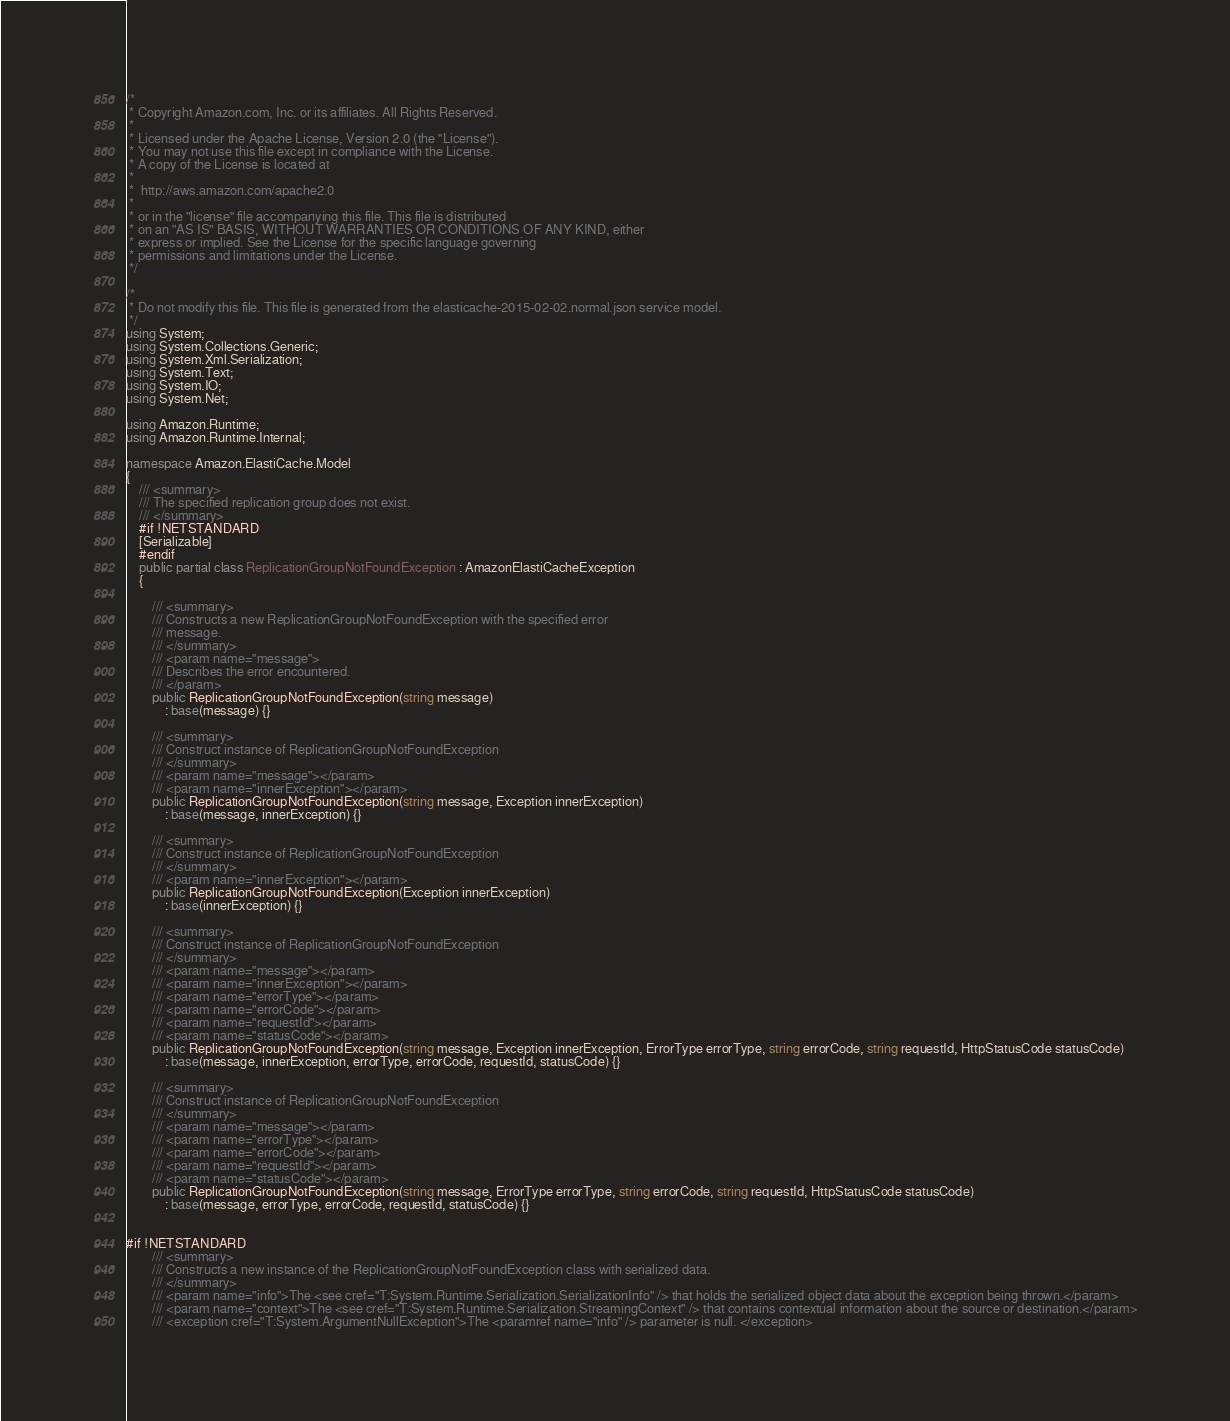Convert code to text. <code><loc_0><loc_0><loc_500><loc_500><_C#_>/*
 * Copyright Amazon.com, Inc. or its affiliates. All Rights Reserved.
 * 
 * Licensed under the Apache License, Version 2.0 (the "License").
 * You may not use this file except in compliance with the License.
 * A copy of the License is located at
 * 
 *  http://aws.amazon.com/apache2.0
 * 
 * or in the "license" file accompanying this file. This file is distributed
 * on an "AS IS" BASIS, WITHOUT WARRANTIES OR CONDITIONS OF ANY KIND, either
 * express or implied. See the License for the specific language governing
 * permissions and limitations under the License.
 */

/*
 * Do not modify this file. This file is generated from the elasticache-2015-02-02.normal.json service model.
 */
using System;
using System.Collections.Generic;
using System.Xml.Serialization;
using System.Text;
using System.IO;
using System.Net;

using Amazon.Runtime;
using Amazon.Runtime.Internal;

namespace Amazon.ElastiCache.Model
{
    /// <summary>
    /// The specified replication group does not exist.
    /// </summary>
    #if !NETSTANDARD
    [Serializable]
    #endif
    public partial class ReplicationGroupNotFoundException : AmazonElastiCacheException
    {

        /// <summary>
        /// Constructs a new ReplicationGroupNotFoundException with the specified error
        /// message.
        /// </summary>
        /// <param name="message">
        /// Describes the error encountered.
        /// </param>
        public ReplicationGroupNotFoundException(string message) 
            : base(message) {}

        /// <summary>
        /// Construct instance of ReplicationGroupNotFoundException
        /// </summary>
        /// <param name="message"></param>
        /// <param name="innerException"></param>
        public ReplicationGroupNotFoundException(string message, Exception innerException) 
            : base(message, innerException) {}

        /// <summary>
        /// Construct instance of ReplicationGroupNotFoundException
        /// </summary>
        /// <param name="innerException"></param>
        public ReplicationGroupNotFoundException(Exception innerException) 
            : base(innerException) {}

        /// <summary>
        /// Construct instance of ReplicationGroupNotFoundException
        /// </summary>
        /// <param name="message"></param>
        /// <param name="innerException"></param>
        /// <param name="errorType"></param>
        /// <param name="errorCode"></param>
        /// <param name="requestId"></param>
        /// <param name="statusCode"></param>
        public ReplicationGroupNotFoundException(string message, Exception innerException, ErrorType errorType, string errorCode, string requestId, HttpStatusCode statusCode) 
            : base(message, innerException, errorType, errorCode, requestId, statusCode) {}

        /// <summary>
        /// Construct instance of ReplicationGroupNotFoundException
        /// </summary>
        /// <param name="message"></param>
        /// <param name="errorType"></param>
        /// <param name="errorCode"></param>
        /// <param name="requestId"></param>
        /// <param name="statusCode"></param>
        public ReplicationGroupNotFoundException(string message, ErrorType errorType, string errorCode, string requestId, HttpStatusCode statusCode) 
            : base(message, errorType, errorCode, requestId, statusCode) {}


#if !NETSTANDARD
        /// <summary>
        /// Constructs a new instance of the ReplicationGroupNotFoundException class with serialized data.
        /// </summary>
        /// <param name="info">The <see cref="T:System.Runtime.Serialization.SerializationInfo" /> that holds the serialized object data about the exception being thrown.</param>
        /// <param name="context">The <see cref="T:System.Runtime.Serialization.StreamingContext" /> that contains contextual information about the source or destination.</param>
        /// <exception cref="T:System.ArgumentNullException">The <paramref name="info" /> parameter is null. </exception></code> 